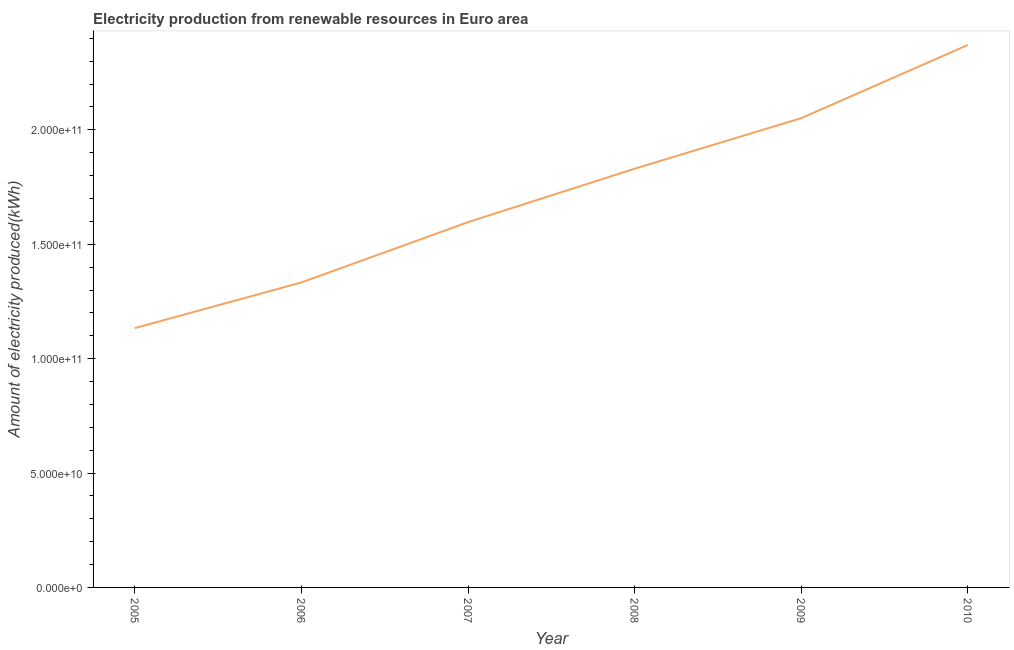What is the amount of electricity produced in 2007?
Provide a short and direct response. 1.60e+11. Across all years, what is the maximum amount of electricity produced?
Offer a very short reply. 2.37e+11. Across all years, what is the minimum amount of electricity produced?
Keep it short and to the point. 1.13e+11. In which year was the amount of electricity produced maximum?
Offer a terse response. 2010. In which year was the amount of electricity produced minimum?
Your answer should be compact. 2005. What is the sum of the amount of electricity produced?
Your answer should be compact. 1.03e+12. What is the difference between the amount of electricity produced in 2007 and 2010?
Make the answer very short. -7.74e+1. What is the average amount of electricity produced per year?
Provide a succinct answer. 1.72e+11. What is the median amount of electricity produced?
Provide a succinct answer. 1.71e+11. What is the ratio of the amount of electricity produced in 2009 to that in 2010?
Provide a succinct answer. 0.87. Is the amount of electricity produced in 2006 less than that in 2008?
Make the answer very short. Yes. Is the difference between the amount of electricity produced in 2005 and 2009 greater than the difference between any two years?
Ensure brevity in your answer.  No. What is the difference between the highest and the second highest amount of electricity produced?
Provide a short and direct response. 3.20e+1. Is the sum of the amount of electricity produced in 2006 and 2008 greater than the maximum amount of electricity produced across all years?
Provide a succinct answer. Yes. What is the difference between the highest and the lowest amount of electricity produced?
Provide a succinct answer. 1.24e+11. What is the difference between two consecutive major ticks on the Y-axis?
Provide a succinct answer. 5.00e+1. Are the values on the major ticks of Y-axis written in scientific E-notation?
Your answer should be compact. Yes. Does the graph contain grids?
Ensure brevity in your answer.  No. What is the title of the graph?
Offer a very short reply. Electricity production from renewable resources in Euro area. What is the label or title of the Y-axis?
Provide a short and direct response. Amount of electricity produced(kWh). What is the Amount of electricity produced(kWh) in 2005?
Provide a succinct answer. 1.13e+11. What is the Amount of electricity produced(kWh) in 2006?
Provide a succinct answer. 1.33e+11. What is the Amount of electricity produced(kWh) in 2007?
Provide a short and direct response. 1.60e+11. What is the Amount of electricity produced(kWh) in 2008?
Offer a terse response. 1.83e+11. What is the Amount of electricity produced(kWh) in 2009?
Give a very brief answer. 2.05e+11. What is the Amount of electricity produced(kWh) of 2010?
Your answer should be compact. 2.37e+11. What is the difference between the Amount of electricity produced(kWh) in 2005 and 2006?
Make the answer very short. -2.00e+1. What is the difference between the Amount of electricity produced(kWh) in 2005 and 2007?
Provide a succinct answer. -4.63e+1. What is the difference between the Amount of electricity produced(kWh) in 2005 and 2008?
Provide a short and direct response. -6.97e+1. What is the difference between the Amount of electricity produced(kWh) in 2005 and 2009?
Make the answer very short. -9.18e+1. What is the difference between the Amount of electricity produced(kWh) in 2005 and 2010?
Give a very brief answer. -1.24e+11. What is the difference between the Amount of electricity produced(kWh) in 2006 and 2007?
Ensure brevity in your answer.  -2.64e+1. What is the difference between the Amount of electricity produced(kWh) in 2006 and 2008?
Ensure brevity in your answer.  -4.97e+1. What is the difference between the Amount of electricity produced(kWh) in 2006 and 2009?
Your answer should be very brief. -7.18e+1. What is the difference between the Amount of electricity produced(kWh) in 2006 and 2010?
Make the answer very short. -1.04e+11. What is the difference between the Amount of electricity produced(kWh) in 2007 and 2008?
Offer a terse response. -2.34e+1. What is the difference between the Amount of electricity produced(kWh) in 2007 and 2009?
Your response must be concise. -4.55e+1. What is the difference between the Amount of electricity produced(kWh) in 2007 and 2010?
Give a very brief answer. -7.74e+1. What is the difference between the Amount of electricity produced(kWh) in 2008 and 2009?
Provide a succinct answer. -2.21e+1. What is the difference between the Amount of electricity produced(kWh) in 2008 and 2010?
Provide a succinct answer. -5.41e+1. What is the difference between the Amount of electricity produced(kWh) in 2009 and 2010?
Your answer should be compact. -3.20e+1. What is the ratio of the Amount of electricity produced(kWh) in 2005 to that in 2007?
Give a very brief answer. 0.71. What is the ratio of the Amount of electricity produced(kWh) in 2005 to that in 2008?
Your answer should be very brief. 0.62. What is the ratio of the Amount of electricity produced(kWh) in 2005 to that in 2009?
Offer a very short reply. 0.55. What is the ratio of the Amount of electricity produced(kWh) in 2005 to that in 2010?
Your answer should be compact. 0.48. What is the ratio of the Amount of electricity produced(kWh) in 2006 to that in 2007?
Your answer should be compact. 0.83. What is the ratio of the Amount of electricity produced(kWh) in 2006 to that in 2008?
Your response must be concise. 0.73. What is the ratio of the Amount of electricity produced(kWh) in 2006 to that in 2009?
Offer a very short reply. 0.65. What is the ratio of the Amount of electricity produced(kWh) in 2006 to that in 2010?
Your response must be concise. 0.56. What is the ratio of the Amount of electricity produced(kWh) in 2007 to that in 2008?
Ensure brevity in your answer.  0.87. What is the ratio of the Amount of electricity produced(kWh) in 2007 to that in 2009?
Your response must be concise. 0.78. What is the ratio of the Amount of electricity produced(kWh) in 2007 to that in 2010?
Provide a short and direct response. 0.67. What is the ratio of the Amount of electricity produced(kWh) in 2008 to that in 2009?
Keep it short and to the point. 0.89. What is the ratio of the Amount of electricity produced(kWh) in 2008 to that in 2010?
Ensure brevity in your answer.  0.77. What is the ratio of the Amount of electricity produced(kWh) in 2009 to that in 2010?
Your answer should be compact. 0.86. 